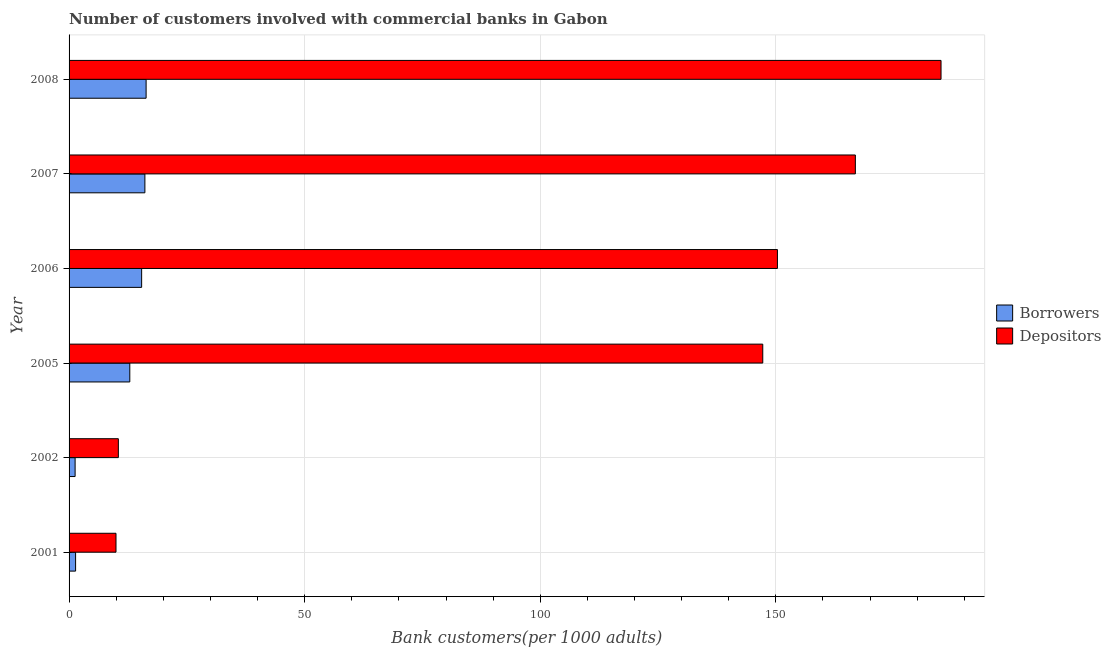How many different coloured bars are there?
Give a very brief answer. 2. Are the number of bars on each tick of the Y-axis equal?
Give a very brief answer. Yes. How many bars are there on the 4th tick from the top?
Your response must be concise. 2. How many bars are there on the 6th tick from the bottom?
Provide a succinct answer. 2. What is the number of depositors in 2001?
Make the answer very short. 9.96. Across all years, what is the maximum number of borrowers?
Give a very brief answer. 16.35. Across all years, what is the minimum number of depositors?
Make the answer very short. 9.96. What is the total number of borrowers in the graph?
Your answer should be very brief. 63.4. What is the difference between the number of borrowers in 2002 and that in 2008?
Offer a terse response. -15.07. What is the difference between the number of borrowers in 2001 and the number of depositors in 2007?
Your response must be concise. -165.49. What is the average number of borrowers per year?
Make the answer very short. 10.57. In the year 2008, what is the difference between the number of borrowers and number of depositors?
Keep it short and to the point. -168.71. What is the ratio of the number of depositors in 2001 to that in 2005?
Offer a terse response. 0.07. Is the number of borrowers in 2002 less than that in 2006?
Provide a short and direct response. Yes. What is the difference between the highest and the second highest number of depositors?
Offer a terse response. 18.18. What is the difference between the highest and the lowest number of borrowers?
Your answer should be compact. 15.07. Is the sum of the number of borrowers in 2001 and 2005 greater than the maximum number of depositors across all years?
Provide a short and direct response. No. What does the 2nd bar from the top in 2006 represents?
Your answer should be compact. Borrowers. What does the 2nd bar from the bottom in 2005 represents?
Offer a terse response. Depositors. What is the difference between two consecutive major ticks on the X-axis?
Provide a short and direct response. 50. Does the graph contain any zero values?
Your answer should be very brief. No. Does the graph contain grids?
Offer a very short reply. Yes. Where does the legend appear in the graph?
Make the answer very short. Center right. How are the legend labels stacked?
Give a very brief answer. Vertical. What is the title of the graph?
Provide a succinct answer. Number of customers involved with commercial banks in Gabon. Does "Boys" appear as one of the legend labels in the graph?
Keep it short and to the point. No. What is the label or title of the X-axis?
Give a very brief answer. Bank customers(per 1000 adults). What is the label or title of the Y-axis?
Offer a very short reply. Year. What is the Bank customers(per 1000 adults) of Borrowers in 2001?
Ensure brevity in your answer.  1.38. What is the Bank customers(per 1000 adults) in Depositors in 2001?
Your answer should be compact. 9.96. What is the Bank customers(per 1000 adults) in Borrowers in 2002?
Your answer should be compact. 1.28. What is the Bank customers(per 1000 adults) of Depositors in 2002?
Offer a terse response. 10.46. What is the Bank customers(per 1000 adults) of Borrowers in 2005?
Ensure brevity in your answer.  12.89. What is the Bank customers(per 1000 adults) in Depositors in 2005?
Your answer should be compact. 147.22. What is the Bank customers(per 1000 adults) of Borrowers in 2006?
Keep it short and to the point. 15.4. What is the Bank customers(per 1000 adults) in Depositors in 2006?
Give a very brief answer. 150.34. What is the Bank customers(per 1000 adults) in Borrowers in 2007?
Ensure brevity in your answer.  16.09. What is the Bank customers(per 1000 adults) of Depositors in 2007?
Your answer should be compact. 166.87. What is the Bank customers(per 1000 adults) of Borrowers in 2008?
Offer a terse response. 16.35. What is the Bank customers(per 1000 adults) in Depositors in 2008?
Provide a short and direct response. 185.06. Across all years, what is the maximum Bank customers(per 1000 adults) in Borrowers?
Your answer should be compact. 16.35. Across all years, what is the maximum Bank customers(per 1000 adults) of Depositors?
Your response must be concise. 185.06. Across all years, what is the minimum Bank customers(per 1000 adults) of Borrowers?
Offer a very short reply. 1.28. Across all years, what is the minimum Bank customers(per 1000 adults) of Depositors?
Your response must be concise. 9.96. What is the total Bank customers(per 1000 adults) in Borrowers in the graph?
Offer a very short reply. 63.4. What is the total Bank customers(per 1000 adults) of Depositors in the graph?
Keep it short and to the point. 669.91. What is the difference between the Bank customers(per 1000 adults) in Borrowers in 2001 and that in 2002?
Provide a succinct answer. 0.1. What is the difference between the Bank customers(per 1000 adults) in Depositors in 2001 and that in 2002?
Give a very brief answer. -0.5. What is the difference between the Bank customers(per 1000 adults) in Borrowers in 2001 and that in 2005?
Offer a terse response. -11.5. What is the difference between the Bank customers(per 1000 adults) of Depositors in 2001 and that in 2005?
Offer a terse response. -137.26. What is the difference between the Bank customers(per 1000 adults) in Borrowers in 2001 and that in 2006?
Give a very brief answer. -14.02. What is the difference between the Bank customers(per 1000 adults) in Depositors in 2001 and that in 2006?
Provide a short and direct response. -140.38. What is the difference between the Bank customers(per 1000 adults) of Borrowers in 2001 and that in 2007?
Your response must be concise. -14.71. What is the difference between the Bank customers(per 1000 adults) of Depositors in 2001 and that in 2007?
Keep it short and to the point. -156.91. What is the difference between the Bank customers(per 1000 adults) of Borrowers in 2001 and that in 2008?
Provide a succinct answer. -14.97. What is the difference between the Bank customers(per 1000 adults) of Depositors in 2001 and that in 2008?
Your answer should be very brief. -175.1. What is the difference between the Bank customers(per 1000 adults) of Borrowers in 2002 and that in 2005?
Your response must be concise. -11.61. What is the difference between the Bank customers(per 1000 adults) of Depositors in 2002 and that in 2005?
Offer a terse response. -136.76. What is the difference between the Bank customers(per 1000 adults) of Borrowers in 2002 and that in 2006?
Keep it short and to the point. -14.12. What is the difference between the Bank customers(per 1000 adults) in Depositors in 2002 and that in 2006?
Offer a terse response. -139.88. What is the difference between the Bank customers(per 1000 adults) in Borrowers in 2002 and that in 2007?
Give a very brief answer. -14.81. What is the difference between the Bank customers(per 1000 adults) of Depositors in 2002 and that in 2007?
Your response must be concise. -156.41. What is the difference between the Bank customers(per 1000 adults) in Borrowers in 2002 and that in 2008?
Provide a short and direct response. -15.07. What is the difference between the Bank customers(per 1000 adults) of Depositors in 2002 and that in 2008?
Make the answer very short. -174.6. What is the difference between the Bank customers(per 1000 adults) in Borrowers in 2005 and that in 2006?
Provide a succinct answer. -2.51. What is the difference between the Bank customers(per 1000 adults) of Depositors in 2005 and that in 2006?
Your answer should be very brief. -3.11. What is the difference between the Bank customers(per 1000 adults) in Borrowers in 2005 and that in 2007?
Keep it short and to the point. -3.2. What is the difference between the Bank customers(per 1000 adults) in Depositors in 2005 and that in 2007?
Your response must be concise. -19.65. What is the difference between the Bank customers(per 1000 adults) in Borrowers in 2005 and that in 2008?
Give a very brief answer. -3.46. What is the difference between the Bank customers(per 1000 adults) of Depositors in 2005 and that in 2008?
Keep it short and to the point. -37.83. What is the difference between the Bank customers(per 1000 adults) in Borrowers in 2006 and that in 2007?
Your answer should be compact. -0.69. What is the difference between the Bank customers(per 1000 adults) of Depositors in 2006 and that in 2007?
Make the answer very short. -16.54. What is the difference between the Bank customers(per 1000 adults) in Borrowers in 2006 and that in 2008?
Give a very brief answer. -0.95. What is the difference between the Bank customers(per 1000 adults) of Depositors in 2006 and that in 2008?
Provide a short and direct response. -34.72. What is the difference between the Bank customers(per 1000 adults) of Borrowers in 2007 and that in 2008?
Give a very brief answer. -0.26. What is the difference between the Bank customers(per 1000 adults) in Depositors in 2007 and that in 2008?
Your answer should be compact. -18.18. What is the difference between the Bank customers(per 1000 adults) of Borrowers in 2001 and the Bank customers(per 1000 adults) of Depositors in 2002?
Offer a terse response. -9.08. What is the difference between the Bank customers(per 1000 adults) in Borrowers in 2001 and the Bank customers(per 1000 adults) in Depositors in 2005?
Give a very brief answer. -145.84. What is the difference between the Bank customers(per 1000 adults) of Borrowers in 2001 and the Bank customers(per 1000 adults) of Depositors in 2006?
Offer a very short reply. -148.95. What is the difference between the Bank customers(per 1000 adults) in Borrowers in 2001 and the Bank customers(per 1000 adults) in Depositors in 2007?
Give a very brief answer. -165.49. What is the difference between the Bank customers(per 1000 adults) of Borrowers in 2001 and the Bank customers(per 1000 adults) of Depositors in 2008?
Provide a succinct answer. -183.67. What is the difference between the Bank customers(per 1000 adults) of Borrowers in 2002 and the Bank customers(per 1000 adults) of Depositors in 2005?
Give a very brief answer. -145.94. What is the difference between the Bank customers(per 1000 adults) in Borrowers in 2002 and the Bank customers(per 1000 adults) in Depositors in 2006?
Offer a very short reply. -149.06. What is the difference between the Bank customers(per 1000 adults) in Borrowers in 2002 and the Bank customers(per 1000 adults) in Depositors in 2007?
Offer a very short reply. -165.59. What is the difference between the Bank customers(per 1000 adults) in Borrowers in 2002 and the Bank customers(per 1000 adults) in Depositors in 2008?
Your answer should be very brief. -183.77. What is the difference between the Bank customers(per 1000 adults) in Borrowers in 2005 and the Bank customers(per 1000 adults) in Depositors in 2006?
Your answer should be very brief. -137.45. What is the difference between the Bank customers(per 1000 adults) of Borrowers in 2005 and the Bank customers(per 1000 adults) of Depositors in 2007?
Make the answer very short. -153.99. What is the difference between the Bank customers(per 1000 adults) of Borrowers in 2005 and the Bank customers(per 1000 adults) of Depositors in 2008?
Your response must be concise. -172.17. What is the difference between the Bank customers(per 1000 adults) of Borrowers in 2006 and the Bank customers(per 1000 adults) of Depositors in 2007?
Make the answer very short. -151.47. What is the difference between the Bank customers(per 1000 adults) of Borrowers in 2006 and the Bank customers(per 1000 adults) of Depositors in 2008?
Offer a very short reply. -169.66. What is the difference between the Bank customers(per 1000 adults) of Borrowers in 2007 and the Bank customers(per 1000 adults) of Depositors in 2008?
Provide a short and direct response. -168.97. What is the average Bank customers(per 1000 adults) in Borrowers per year?
Your answer should be very brief. 10.57. What is the average Bank customers(per 1000 adults) of Depositors per year?
Your answer should be very brief. 111.65. In the year 2001, what is the difference between the Bank customers(per 1000 adults) of Borrowers and Bank customers(per 1000 adults) of Depositors?
Keep it short and to the point. -8.57. In the year 2002, what is the difference between the Bank customers(per 1000 adults) of Borrowers and Bank customers(per 1000 adults) of Depositors?
Provide a succinct answer. -9.18. In the year 2005, what is the difference between the Bank customers(per 1000 adults) of Borrowers and Bank customers(per 1000 adults) of Depositors?
Keep it short and to the point. -134.33. In the year 2006, what is the difference between the Bank customers(per 1000 adults) in Borrowers and Bank customers(per 1000 adults) in Depositors?
Your answer should be very brief. -134.94. In the year 2007, what is the difference between the Bank customers(per 1000 adults) in Borrowers and Bank customers(per 1000 adults) in Depositors?
Your response must be concise. -150.78. In the year 2008, what is the difference between the Bank customers(per 1000 adults) of Borrowers and Bank customers(per 1000 adults) of Depositors?
Make the answer very short. -168.71. What is the ratio of the Bank customers(per 1000 adults) in Borrowers in 2001 to that in 2002?
Give a very brief answer. 1.08. What is the ratio of the Bank customers(per 1000 adults) of Depositors in 2001 to that in 2002?
Provide a succinct answer. 0.95. What is the ratio of the Bank customers(per 1000 adults) of Borrowers in 2001 to that in 2005?
Make the answer very short. 0.11. What is the ratio of the Bank customers(per 1000 adults) of Depositors in 2001 to that in 2005?
Make the answer very short. 0.07. What is the ratio of the Bank customers(per 1000 adults) in Borrowers in 2001 to that in 2006?
Ensure brevity in your answer.  0.09. What is the ratio of the Bank customers(per 1000 adults) of Depositors in 2001 to that in 2006?
Ensure brevity in your answer.  0.07. What is the ratio of the Bank customers(per 1000 adults) in Borrowers in 2001 to that in 2007?
Give a very brief answer. 0.09. What is the ratio of the Bank customers(per 1000 adults) of Depositors in 2001 to that in 2007?
Your answer should be very brief. 0.06. What is the ratio of the Bank customers(per 1000 adults) of Borrowers in 2001 to that in 2008?
Provide a succinct answer. 0.08. What is the ratio of the Bank customers(per 1000 adults) of Depositors in 2001 to that in 2008?
Your response must be concise. 0.05. What is the ratio of the Bank customers(per 1000 adults) of Borrowers in 2002 to that in 2005?
Provide a succinct answer. 0.1. What is the ratio of the Bank customers(per 1000 adults) in Depositors in 2002 to that in 2005?
Make the answer very short. 0.07. What is the ratio of the Bank customers(per 1000 adults) of Borrowers in 2002 to that in 2006?
Offer a terse response. 0.08. What is the ratio of the Bank customers(per 1000 adults) in Depositors in 2002 to that in 2006?
Ensure brevity in your answer.  0.07. What is the ratio of the Bank customers(per 1000 adults) in Borrowers in 2002 to that in 2007?
Provide a succinct answer. 0.08. What is the ratio of the Bank customers(per 1000 adults) in Depositors in 2002 to that in 2007?
Provide a short and direct response. 0.06. What is the ratio of the Bank customers(per 1000 adults) in Borrowers in 2002 to that in 2008?
Make the answer very short. 0.08. What is the ratio of the Bank customers(per 1000 adults) of Depositors in 2002 to that in 2008?
Your response must be concise. 0.06. What is the ratio of the Bank customers(per 1000 adults) in Borrowers in 2005 to that in 2006?
Ensure brevity in your answer.  0.84. What is the ratio of the Bank customers(per 1000 adults) in Depositors in 2005 to that in 2006?
Your response must be concise. 0.98. What is the ratio of the Bank customers(per 1000 adults) of Borrowers in 2005 to that in 2007?
Ensure brevity in your answer.  0.8. What is the ratio of the Bank customers(per 1000 adults) of Depositors in 2005 to that in 2007?
Your answer should be very brief. 0.88. What is the ratio of the Bank customers(per 1000 adults) of Borrowers in 2005 to that in 2008?
Provide a short and direct response. 0.79. What is the ratio of the Bank customers(per 1000 adults) in Depositors in 2005 to that in 2008?
Keep it short and to the point. 0.8. What is the ratio of the Bank customers(per 1000 adults) in Borrowers in 2006 to that in 2007?
Ensure brevity in your answer.  0.96. What is the ratio of the Bank customers(per 1000 adults) of Depositors in 2006 to that in 2007?
Ensure brevity in your answer.  0.9. What is the ratio of the Bank customers(per 1000 adults) of Borrowers in 2006 to that in 2008?
Ensure brevity in your answer.  0.94. What is the ratio of the Bank customers(per 1000 adults) in Depositors in 2006 to that in 2008?
Give a very brief answer. 0.81. What is the ratio of the Bank customers(per 1000 adults) of Borrowers in 2007 to that in 2008?
Your answer should be very brief. 0.98. What is the ratio of the Bank customers(per 1000 adults) in Depositors in 2007 to that in 2008?
Your answer should be very brief. 0.9. What is the difference between the highest and the second highest Bank customers(per 1000 adults) of Borrowers?
Provide a succinct answer. 0.26. What is the difference between the highest and the second highest Bank customers(per 1000 adults) in Depositors?
Give a very brief answer. 18.18. What is the difference between the highest and the lowest Bank customers(per 1000 adults) of Borrowers?
Give a very brief answer. 15.07. What is the difference between the highest and the lowest Bank customers(per 1000 adults) in Depositors?
Provide a short and direct response. 175.1. 